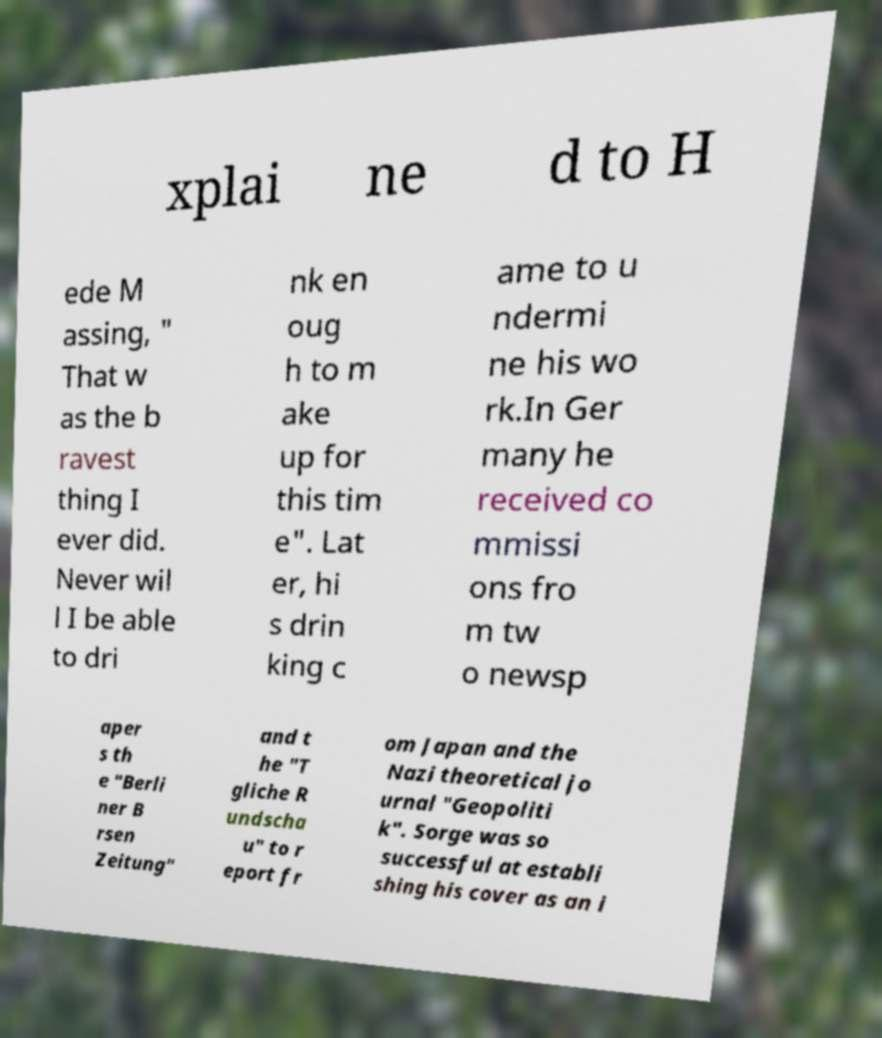For documentation purposes, I need the text within this image transcribed. Could you provide that? xplai ne d to H ede M assing, " That w as the b ravest thing I ever did. Never wil l I be able to dri nk en oug h to m ake up for this tim e". Lat er, hi s drin king c ame to u ndermi ne his wo rk.In Ger many he received co mmissi ons fro m tw o newsp aper s th e "Berli ner B rsen Zeitung" and t he "T gliche R undscha u" to r eport fr om Japan and the Nazi theoretical jo urnal "Geopoliti k". Sorge was so successful at establi shing his cover as an i 